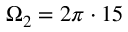Convert formula to latex. <formula><loc_0><loc_0><loc_500><loc_500>\Omega _ { 2 } = 2 \pi \cdot 1 5</formula> 